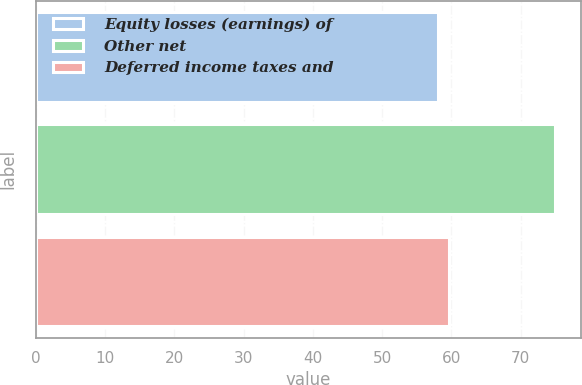Convert chart to OTSL. <chart><loc_0><loc_0><loc_500><loc_500><bar_chart><fcel>Equity losses (earnings) of<fcel>Other net<fcel>Deferred income taxes and<nl><fcel>58<fcel>75<fcel>59.7<nl></chart> 